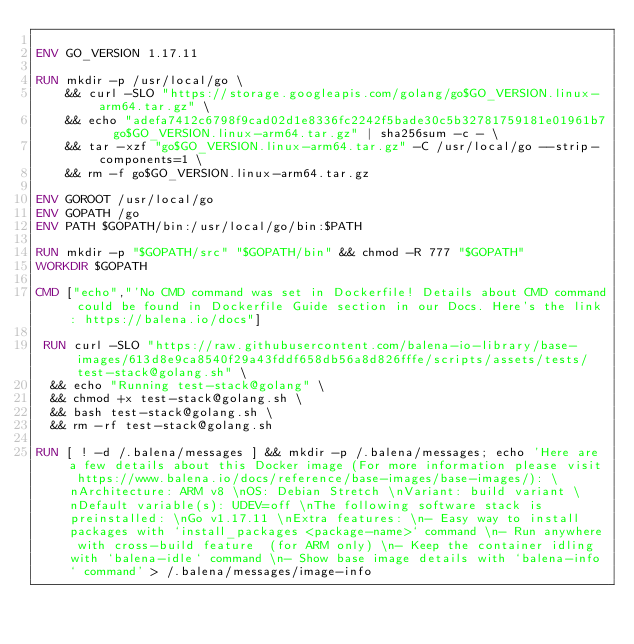Convert code to text. <code><loc_0><loc_0><loc_500><loc_500><_Dockerfile_>
ENV GO_VERSION 1.17.11

RUN mkdir -p /usr/local/go \
	&& curl -SLO "https://storage.googleapis.com/golang/go$GO_VERSION.linux-arm64.tar.gz" \
	&& echo "adefa7412c6798f9cad02d1e8336fc2242f5bade30c5b32781759181e01961b7  go$GO_VERSION.linux-arm64.tar.gz" | sha256sum -c - \
	&& tar -xzf "go$GO_VERSION.linux-arm64.tar.gz" -C /usr/local/go --strip-components=1 \
	&& rm -f go$GO_VERSION.linux-arm64.tar.gz

ENV GOROOT /usr/local/go
ENV GOPATH /go
ENV PATH $GOPATH/bin:/usr/local/go/bin:$PATH

RUN mkdir -p "$GOPATH/src" "$GOPATH/bin" && chmod -R 777 "$GOPATH"
WORKDIR $GOPATH

CMD ["echo","'No CMD command was set in Dockerfile! Details about CMD command could be found in Dockerfile Guide section in our Docs. Here's the link: https://balena.io/docs"]

 RUN curl -SLO "https://raw.githubusercontent.com/balena-io-library/base-images/613d8e9ca8540f29a43fddf658db56a8d826fffe/scripts/assets/tests/test-stack@golang.sh" \
  && echo "Running test-stack@golang" \
  && chmod +x test-stack@golang.sh \
  && bash test-stack@golang.sh \
  && rm -rf test-stack@golang.sh 

RUN [ ! -d /.balena/messages ] && mkdir -p /.balena/messages; echo 'Here are a few details about this Docker image (For more information please visit https://www.balena.io/docs/reference/base-images/base-images/): \nArchitecture: ARM v8 \nOS: Debian Stretch \nVariant: build variant \nDefault variable(s): UDEV=off \nThe following software stack is preinstalled: \nGo v1.17.11 \nExtra features: \n- Easy way to install packages with `install_packages <package-name>` command \n- Run anywhere with cross-build feature  (for ARM only) \n- Keep the container idling with `balena-idle` command \n- Show base image details with `balena-info` command' > /.balena/messages/image-info</code> 